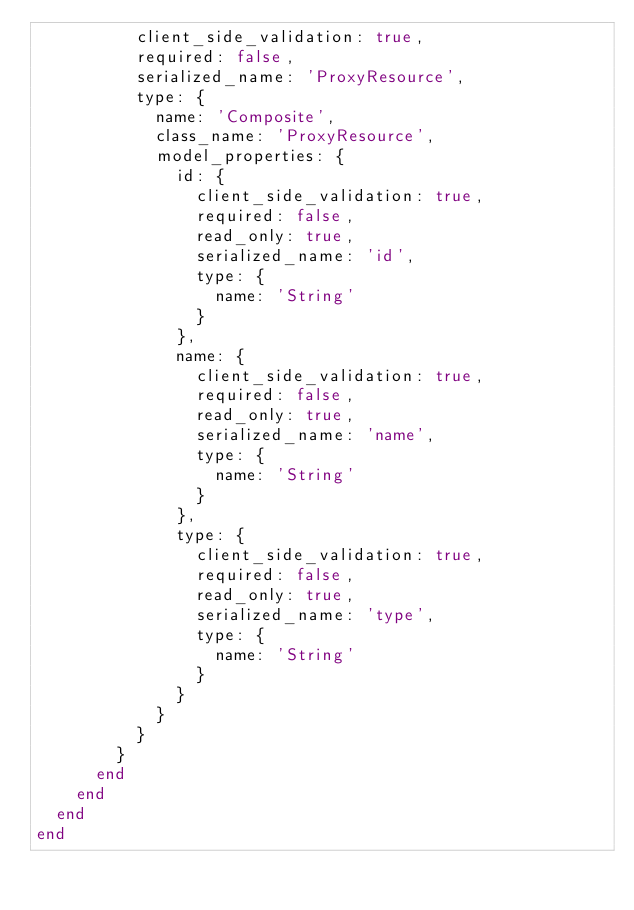Convert code to text. <code><loc_0><loc_0><loc_500><loc_500><_Ruby_>          client_side_validation: true,
          required: false,
          serialized_name: 'ProxyResource',
          type: {
            name: 'Composite',
            class_name: 'ProxyResource',
            model_properties: {
              id: {
                client_side_validation: true,
                required: false,
                read_only: true,
                serialized_name: 'id',
                type: {
                  name: 'String'
                }
              },
              name: {
                client_side_validation: true,
                required: false,
                read_only: true,
                serialized_name: 'name',
                type: {
                  name: 'String'
                }
              },
              type: {
                client_side_validation: true,
                required: false,
                read_only: true,
                serialized_name: 'type',
                type: {
                  name: 'String'
                }
              }
            }
          }
        }
      end
    end
  end
end
</code> 